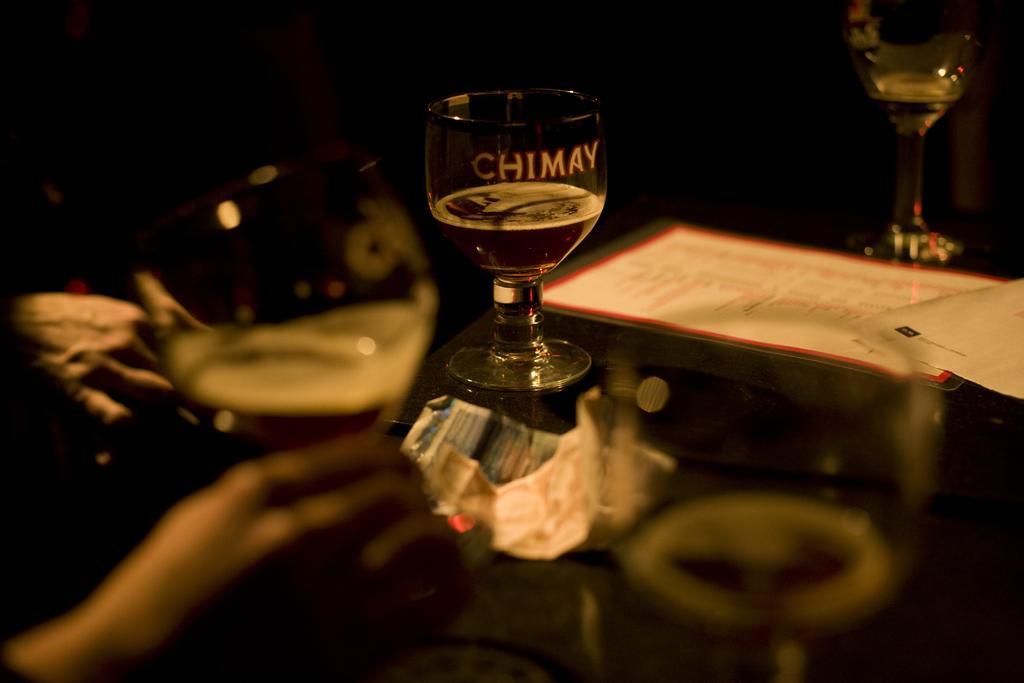In one or two sentences, can you explain what this image depicts? In this image we can see a glass on the table, and paper on it, beside here a person is holding the glass and some liquid in it, there it is dark. 